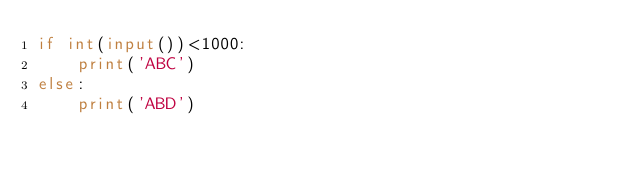<code> <loc_0><loc_0><loc_500><loc_500><_Python_>if int(input())<1000:
    print('ABC')
else:
    print('ABD')</code> 